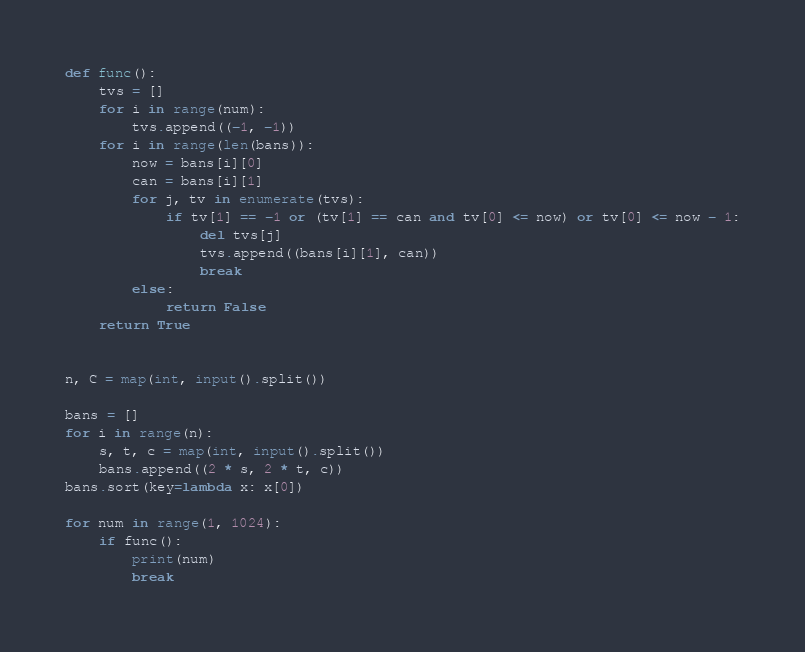Convert code to text. <code><loc_0><loc_0><loc_500><loc_500><_Python_>def func():
    tvs = []
    for i in range(num):
        tvs.append((-1, -1))
    for i in range(len(bans)):
        now = bans[i][0]
        can = bans[i][1]
        for j, tv in enumerate(tvs):
            if tv[1] == -1 or (tv[1] == can and tv[0] <= now) or tv[0] <= now - 1:
                del tvs[j]
                tvs.append((bans[i][1], can))
                break
        else:
            return False
    return True


n, C = map(int, input().split())

bans = []
for i in range(n):
    s, t, c = map(int, input().split())
    bans.append((2 * s, 2 * t, c))
bans.sort(key=lambda x: x[0])

for num in range(1, 1024):
    if func():
        print(num)
        break
</code> 